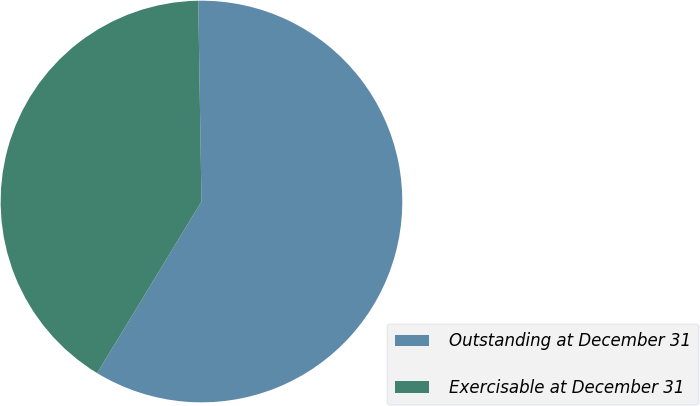<chart> <loc_0><loc_0><loc_500><loc_500><pie_chart><fcel>Outstanding at December 31<fcel>Exercisable at December 31<nl><fcel>58.95%<fcel>41.05%<nl></chart> 